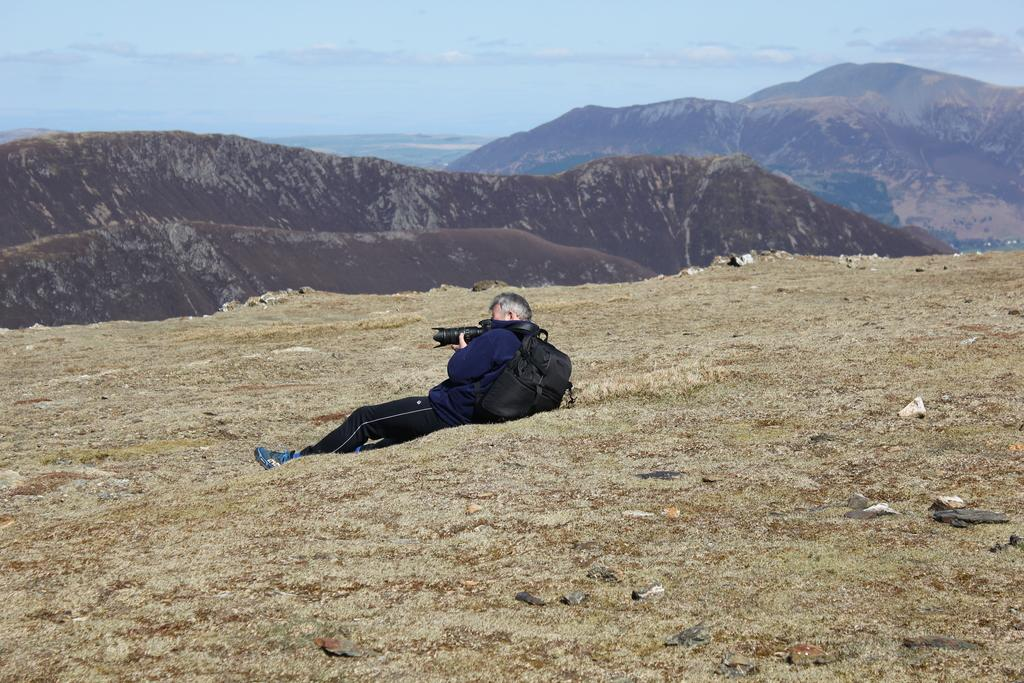What is the person in the image doing? The person is sitting in the image. What is the person holding? The person is holding a camera. What can be seen in the background of the image? There are mountains in the background of the image. What colors are visible in the sky in the image? The sky is blue and white in color. What type of dress is the ant wearing in the image? There is no ant present in the image, and therefore no dress or any other clothing item can be observed. 